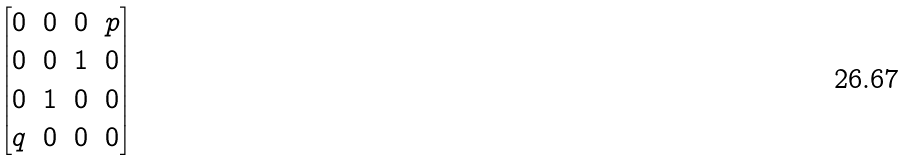Convert formula to latex. <formula><loc_0><loc_0><loc_500><loc_500>\begin{bmatrix} 0 & 0 & 0 & p \\ 0 & 0 & 1 & 0 \\ 0 & 1 & 0 & 0 \\ q & 0 & 0 & 0 \end{bmatrix}</formula> 